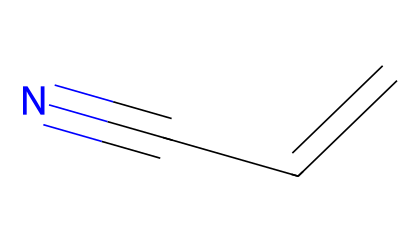What is the molecular formula of acrylonitrile? To determine the molecular formula from the SMILES representation (C=CC#N), we identify the different atoms present: there are 3 carbon atoms, 3 hydrogen atoms, and 1 nitrogen atom. Thus, the molecular formula can be expressed as C3H3N.
Answer: C3H3N How many double bonds are present in acrylonitrile? By examining the SMILES representation, we see that there is one double bond between the first two carbon atoms (C=C) and the triple bond is not a double bond. Therefore, acrylonitrile has one double bond.
Answer: 1 What type of compound is acrylonitrile classified as? Acrylonitrile contains a cyano group (-C≡N), making it a nitrile compound. Since it has a carbon-carbon double bond as well, it is specifically classified as an unsaturated nitrile.
Answer: unsaturated nitrile What is the hybridization of the carbon atoms in the double bond of acrylonitrile? In the double bond (C=C), the carbon atoms will exhibit sp² hybridization because they are involved in a double bond and have one lone pair of electrons. This corresponds to the bonding requirements of double bonds.
Answer: sp² Which part of acrylonitrile contains the nitrogen atom? The nitrogen atom is part of the cyano group (-C≡N), which means it is connected to the last carbon atom in the molecule where the triple bond occurs. Thus, the nitrogen is linked to the carbon at the end of the chain.
Answer: cyano group What is a common use of acrylonitrile? Acrylonitrile is primarily used as a precursor to produce polymers such as acrylic fiber, which is often utilized in the textile industry. This is due to its ability to polymerize into long molecular chains forming plastics.
Answer: acrylic fiber 